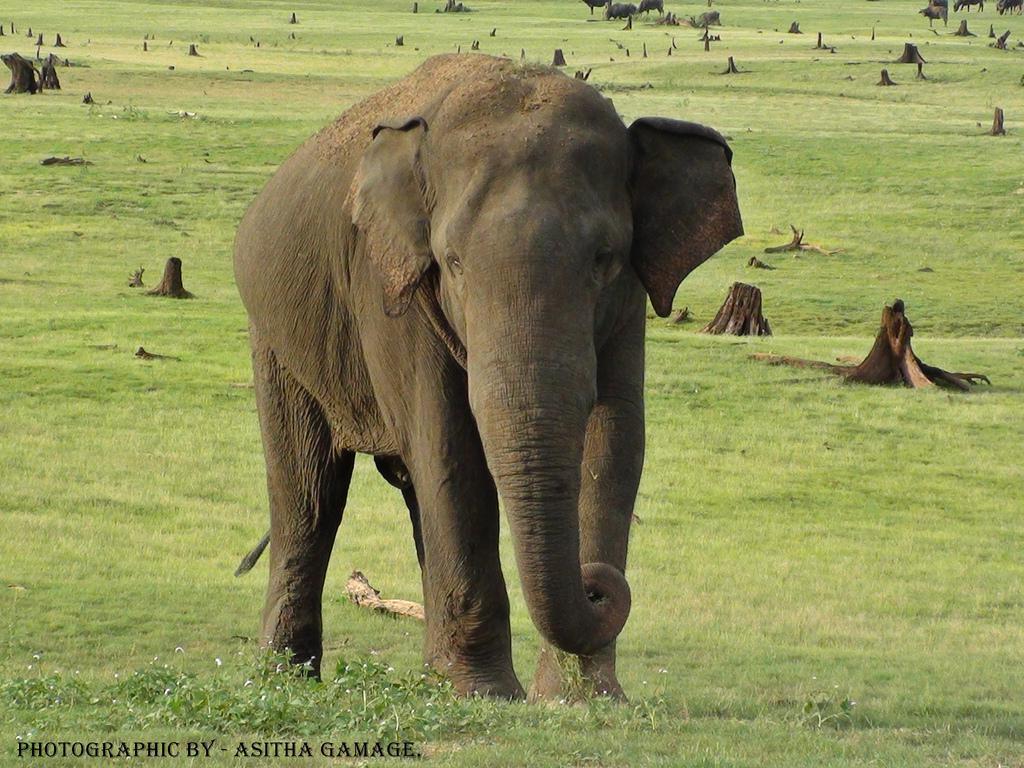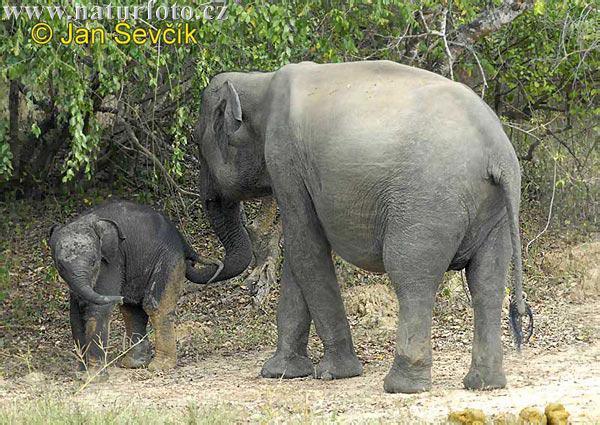The first image is the image on the left, the second image is the image on the right. Evaluate the accuracy of this statement regarding the images: "There is exactly two elephants in the right image.". Is it true? Answer yes or no. Yes. The first image is the image on the left, the second image is the image on the right. Considering the images on both sides, is "The left image shows one lone adult elephant, while the right image shows one adult elephant with one younger elephant beside it" valid? Answer yes or no. Yes. 